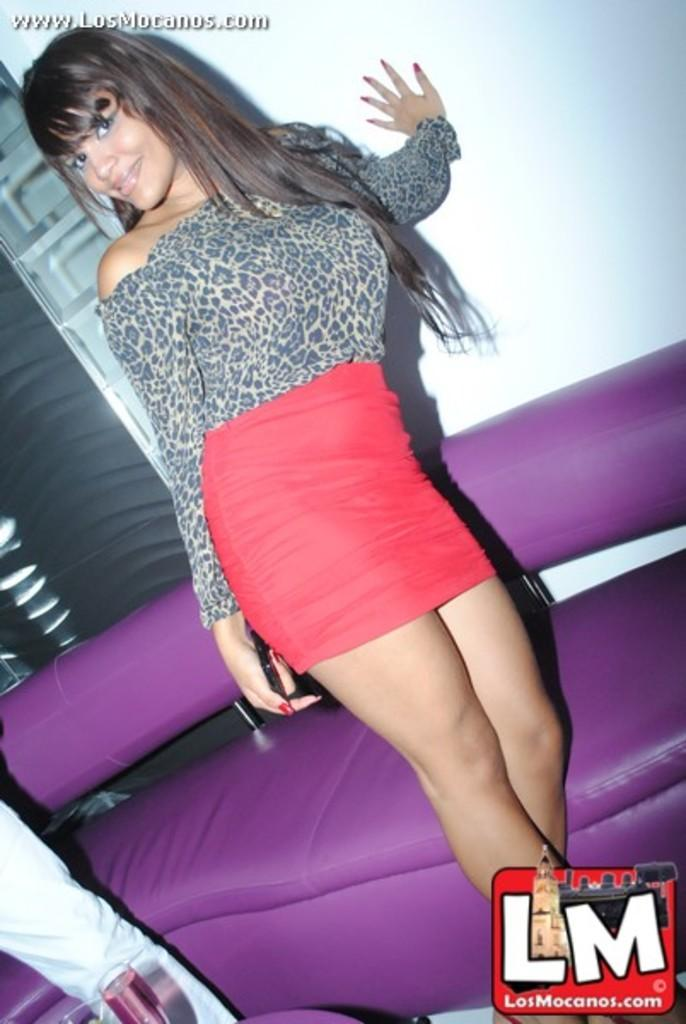Who is present in the image? There is a woman in the image. What is the woman doing in the image? The woman is standing and smiling. What type of furniture is in the image? There is a sofa in the image. What object can be seen in the woman's hand? There is a glass in the image. Who else is present in the image? There is a person beside the woman. What can be seen in the background of the image? There is a wall in the background of the image. What type of flock can be seen flying in the image? There is no flock of birds or animals present in the image. Can you tell me how many copies of the glass are visible in the image? There is only one glass visible in the image, so there are no copies. 